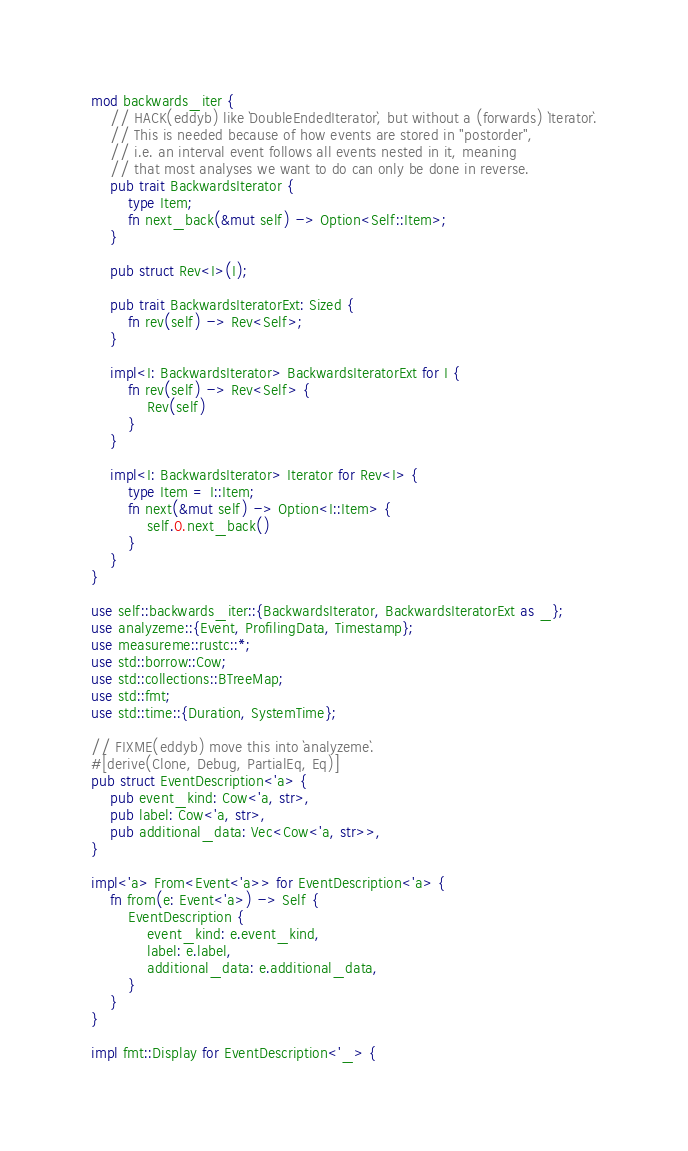Convert code to text. <code><loc_0><loc_0><loc_500><loc_500><_Rust_>mod backwards_iter {
    // HACK(eddyb) like `DoubleEndedIterator`, but without a (forwards) `Iterator`.
    // This is needed because of how events are stored in "postorder",
    // i.e. an interval event follows all events nested in it, meaning
    // that most analyses we want to do can only be done in reverse.
    pub trait BackwardsIterator {
        type Item;
        fn next_back(&mut self) -> Option<Self::Item>;
    }

    pub struct Rev<I>(I);

    pub trait BackwardsIteratorExt: Sized {
        fn rev(self) -> Rev<Self>;
    }

    impl<I: BackwardsIterator> BackwardsIteratorExt for I {
        fn rev(self) -> Rev<Self> {
            Rev(self)
        }
    }

    impl<I: BackwardsIterator> Iterator for Rev<I> {
        type Item = I::Item;
        fn next(&mut self) -> Option<I::Item> {
            self.0.next_back()
        }
    }
}

use self::backwards_iter::{BackwardsIterator, BackwardsIteratorExt as _};
use analyzeme::{Event, ProfilingData, Timestamp};
use measureme::rustc::*;
use std::borrow::Cow;
use std::collections::BTreeMap;
use std::fmt;
use std::time::{Duration, SystemTime};

// FIXME(eddyb) move this into `analyzeme`.
#[derive(Clone, Debug, PartialEq, Eq)]
pub struct EventDescription<'a> {
    pub event_kind: Cow<'a, str>,
    pub label: Cow<'a, str>,
    pub additional_data: Vec<Cow<'a, str>>,
}

impl<'a> From<Event<'a>> for EventDescription<'a> {
    fn from(e: Event<'a>) -> Self {
        EventDescription {
            event_kind: e.event_kind,
            label: e.label,
            additional_data: e.additional_data,
        }
    }
}

impl fmt::Display for EventDescription<'_> {</code> 